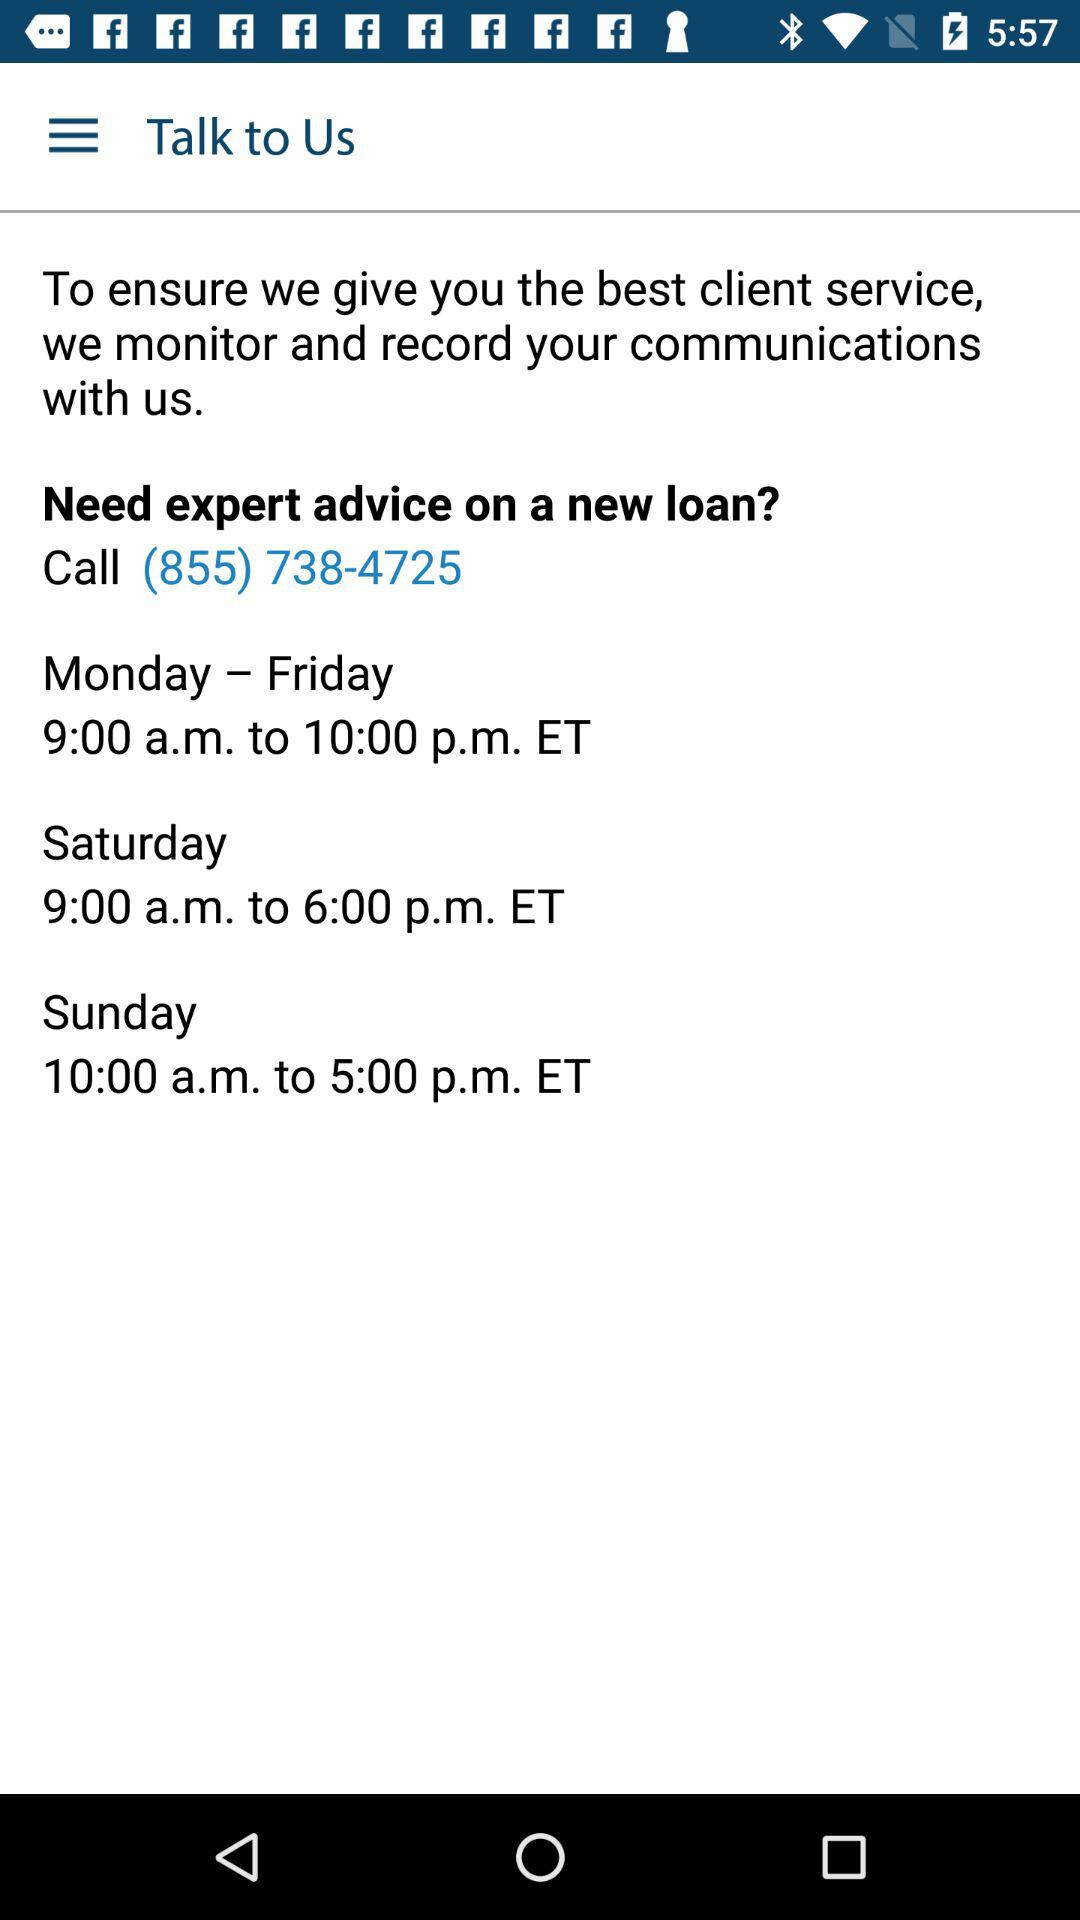What is the time range to call the expert on Sunday? The time range to call the expert on Sunday is from 10:00 a.m. to 5:00 p.m. ET. 